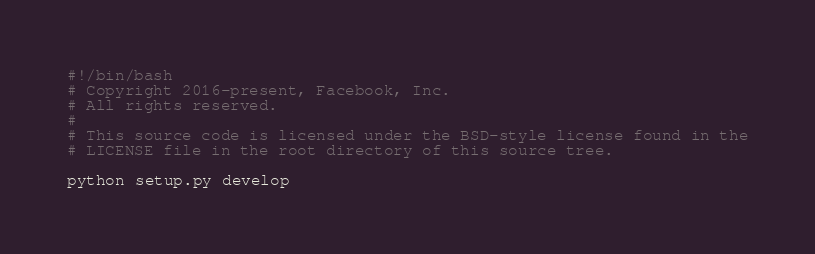Convert code to text. <code><loc_0><loc_0><loc_500><loc_500><_Bash_>#!/bin/bash
# Copyright 2016-present, Facebook, Inc.
# All rights reserved.
#
# This source code is licensed under the BSD-style license found in the
# LICENSE file in the root directory of this source tree.

python setup.py develop

</code> 